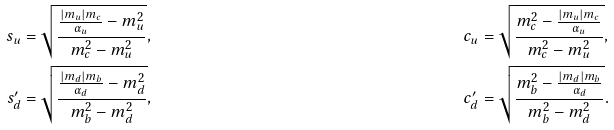Convert formula to latex. <formula><loc_0><loc_0><loc_500><loc_500>s _ { u } & = \sqrt { \frac { \frac { | m _ { u } | m _ { c } } { \alpha _ { u } } - m _ { u } ^ { 2 } } { m _ { c } ^ { 2 } - m _ { u } ^ { 2 } } } , & c _ { u } & = \sqrt { \frac { m _ { c } ^ { 2 } - \frac { | m _ { u } | m _ { c } } { \alpha _ { u } } } { m _ { c } ^ { 2 } - m _ { u } ^ { 2 } } } , \\ s ^ { \prime } _ { d } & = \sqrt { \frac { \frac { | m _ { d } | m _ { b } } { \alpha _ { d } } - m _ { d } ^ { 2 } } { m _ { b } ^ { 2 } - m _ { d } ^ { 2 } } } , & c ^ { \prime } _ { d } & = \sqrt { \frac { m _ { b } ^ { 2 } - \frac { | m _ { d } | m _ { b } } { \alpha _ { d } } } { m _ { b } ^ { 2 } - m _ { d } ^ { 2 } } } .</formula> 